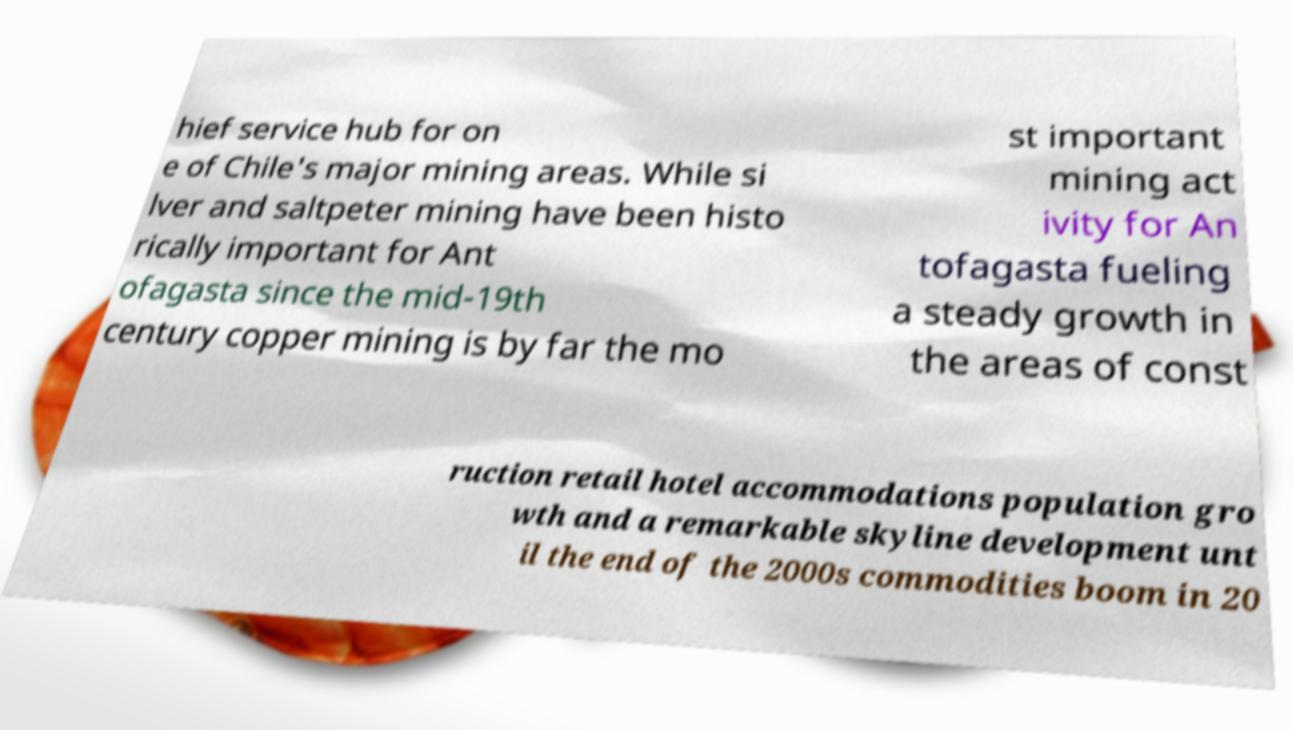What messages or text are displayed in this image? I need them in a readable, typed format. hief service hub for on e of Chile's major mining areas. While si lver and saltpeter mining have been histo rically important for Ant ofagasta since the mid-19th century copper mining is by far the mo st important mining act ivity for An tofagasta fueling a steady growth in the areas of const ruction retail hotel accommodations population gro wth and a remarkable skyline development unt il the end of the 2000s commodities boom in 20 